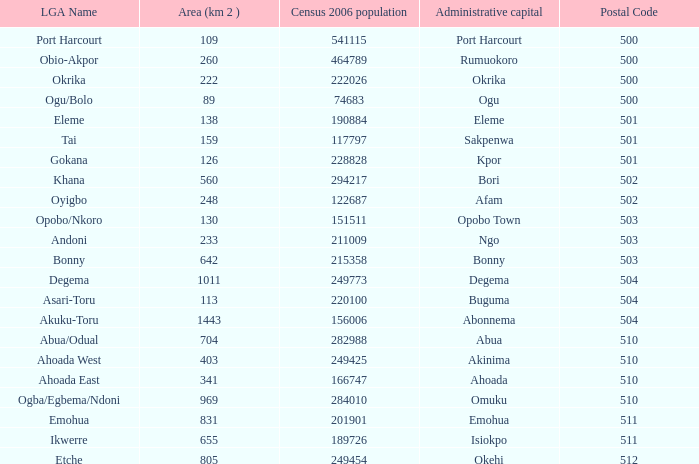When the area is 159, what is the population count from the 2006 census? 1.0. 